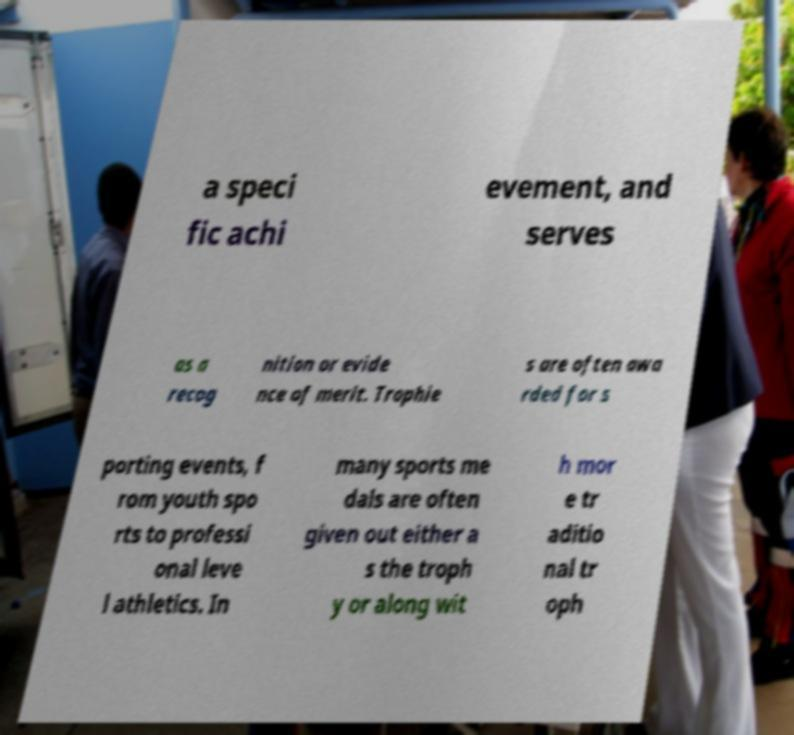What messages or text are displayed in this image? I need them in a readable, typed format. a speci fic achi evement, and serves as a recog nition or evide nce of merit. Trophie s are often awa rded for s porting events, f rom youth spo rts to professi onal leve l athletics. In many sports me dals are often given out either a s the troph y or along wit h mor e tr aditio nal tr oph 